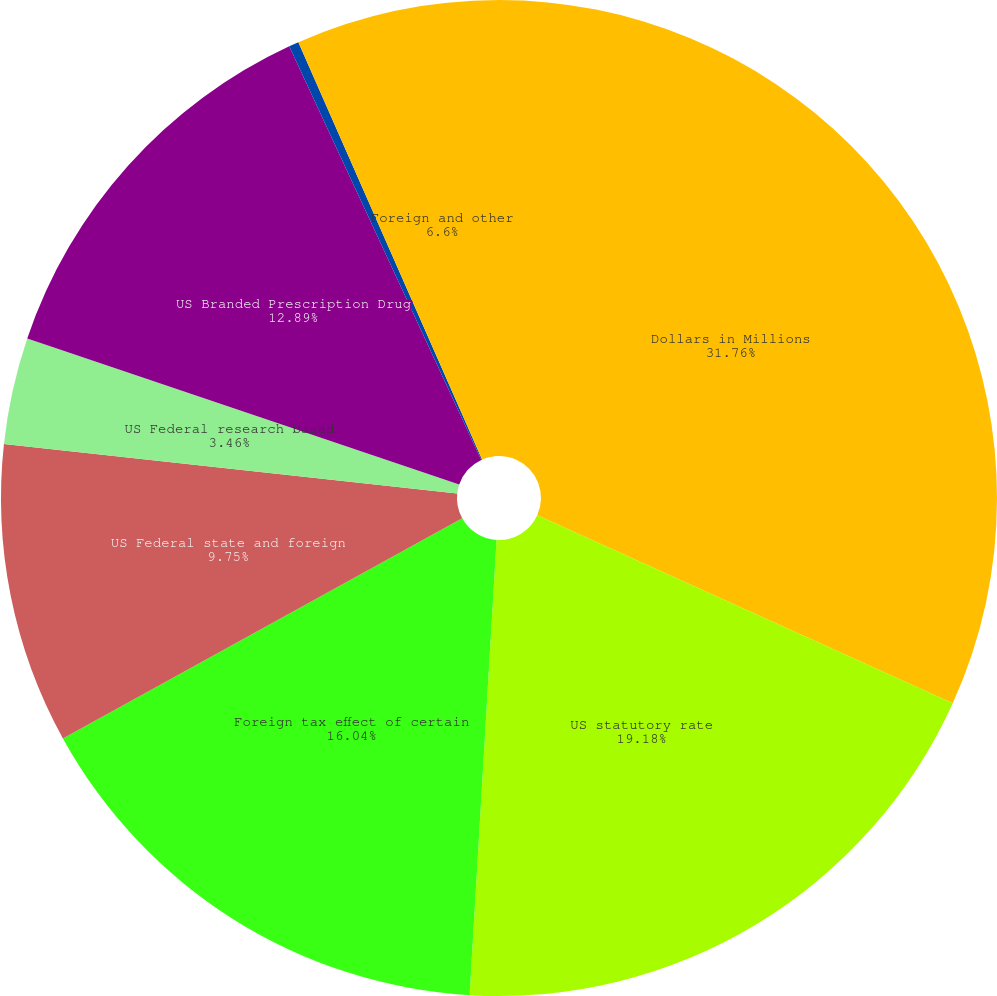Convert chart. <chart><loc_0><loc_0><loc_500><loc_500><pie_chart><fcel>Dollars in Millions<fcel>US statutory rate<fcel>Foreign tax effect of certain<fcel>US Federal state and foreign<fcel>US Federal research based<fcel>US Branded Prescription Drug<fcel>State and local taxes (net of<fcel>Foreign and other<nl><fcel>31.76%<fcel>19.18%<fcel>16.04%<fcel>9.75%<fcel>3.46%<fcel>12.89%<fcel>0.32%<fcel>6.6%<nl></chart> 